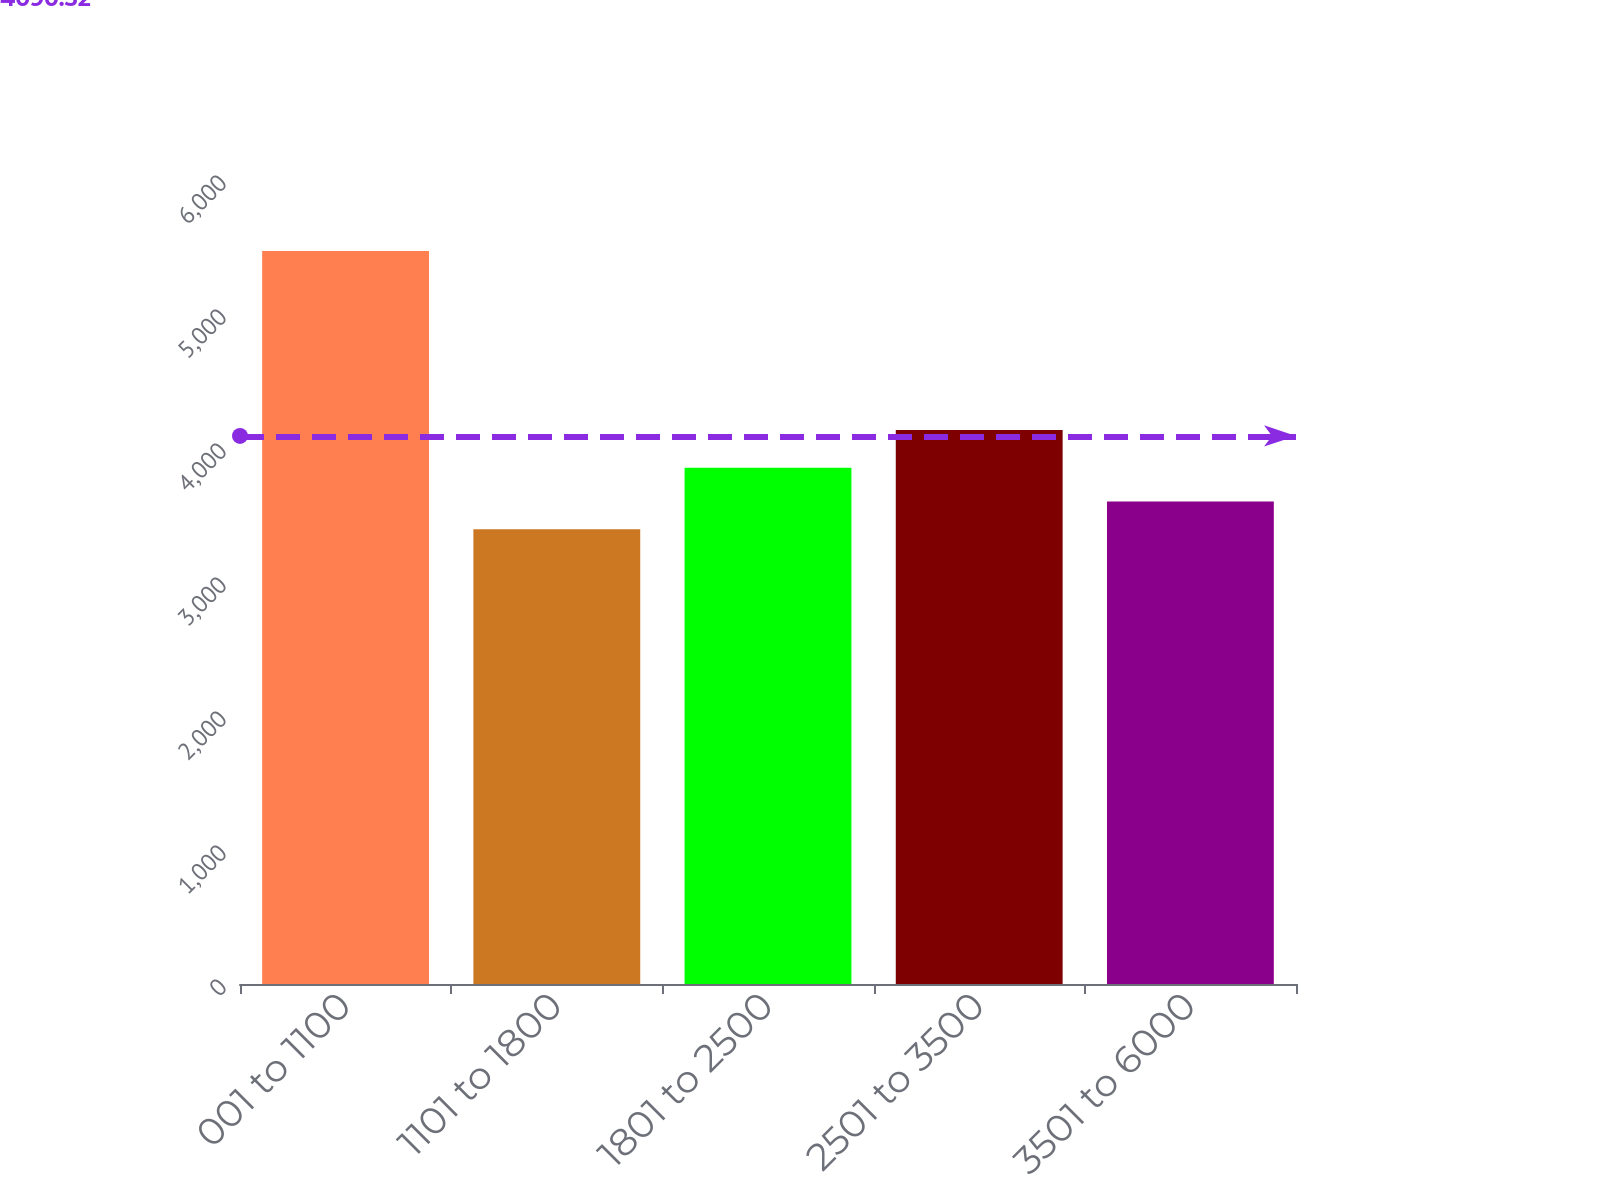<chart> <loc_0><loc_0><loc_500><loc_500><bar_chart><fcel>001 to 1100<fcel>1101 to 1800<fcel>1801 to 2500<fcel>2501 to 3500<fcel>3501 to 6000<nl><fcel>5470<fcel>3394<fcel>3852<fcel>4134<fcel>3601.6<nl></chart> 